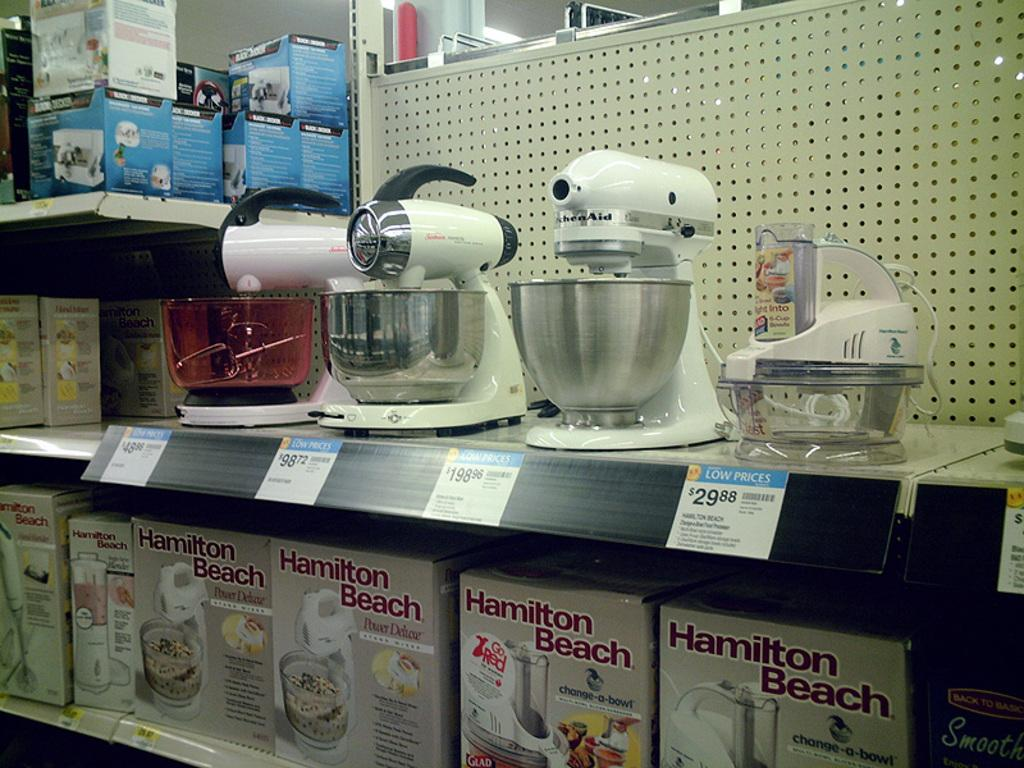<image>
Provide a brief description of the given image. the words Hamilton Beach on a sign under some appliances 